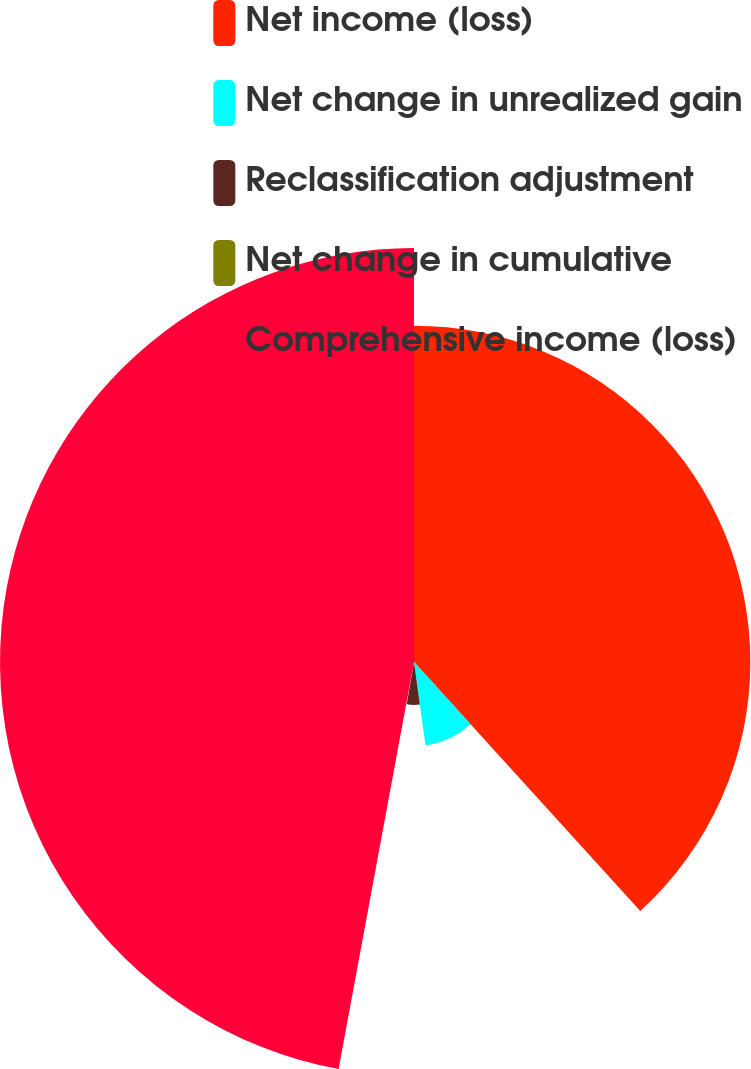<chart> <loc_0><loc_0><loc_500><loc_500><pie_chart><fcel>Net income (loss)<fcel>Net change in unrealized gain<fcel>Reclassification adjustment<fcel>Net change in cumulative<fcel>Comprehensive income (loss)<nl><fcel>38.26%<fcel>9.57%<fcel>4.89%<fcel>0.2%<fcel>47.09%<nl></chart> 